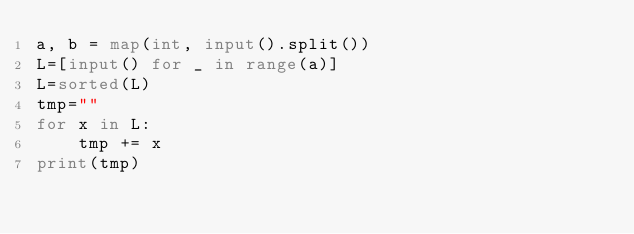Convert code to text. <code><loc_0><loc_0><loc_500><loc_500><_Python_>a, b = map(int, input().split())
L=[input() for _ in range(a)]
L=sorted(L)
tmp=""
for x in L:
    tmp += x
print(tmp)</code> 